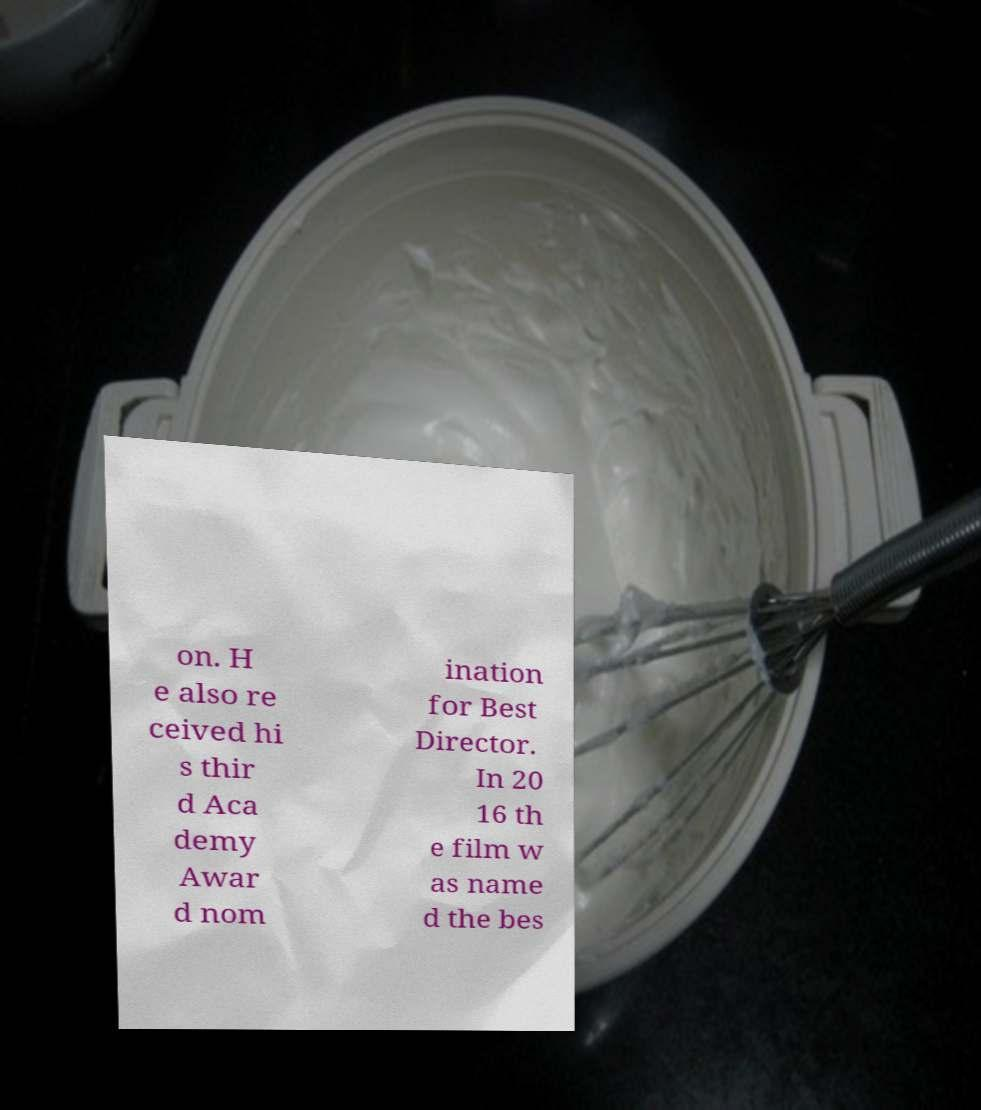Please read and relay the text visible in this image. What does it say? on. H e also re ceived hi s thir d Aca demy Awar d nom ination for Best Director. In 20 16 th e film w as name d the bes 